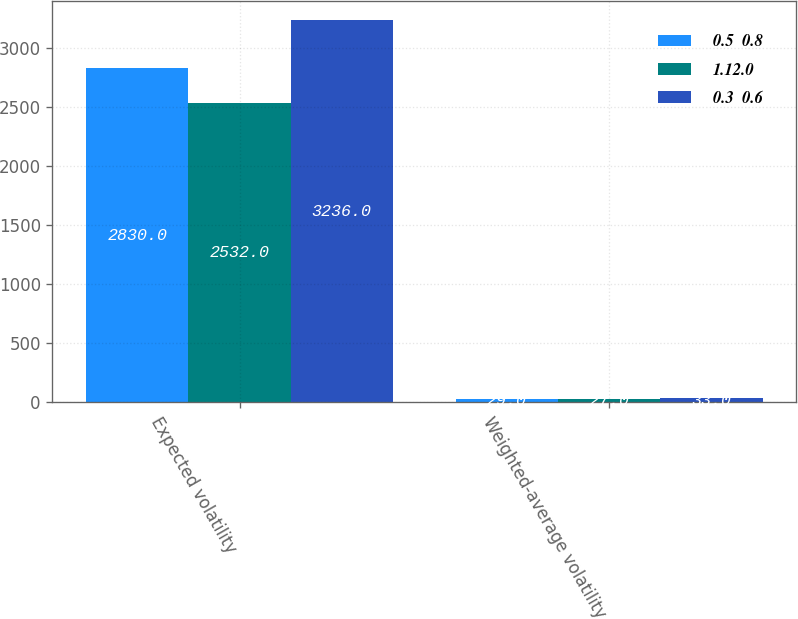Convert chart. <chart><loc_0><loc_0><loc_500><loc_500><stacked_bar_chart><ecel><fcel>Expected volatility<fcel>Weighted-average volatility<nl><fcel>0.5  0.8<fcel>2830<fcel>29<nl><fcel>1.12.0<fcel>2532<fcel>27<nl><fcel>0.3  0.6<fcel>3236<fcel>33<nl></chart> 